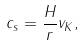Convert formula to latex. <formula><loc_0><loc_0><loc_500><loc_500>c _ { s } = \frac { H } { r } v _ { K } ,</formula> 